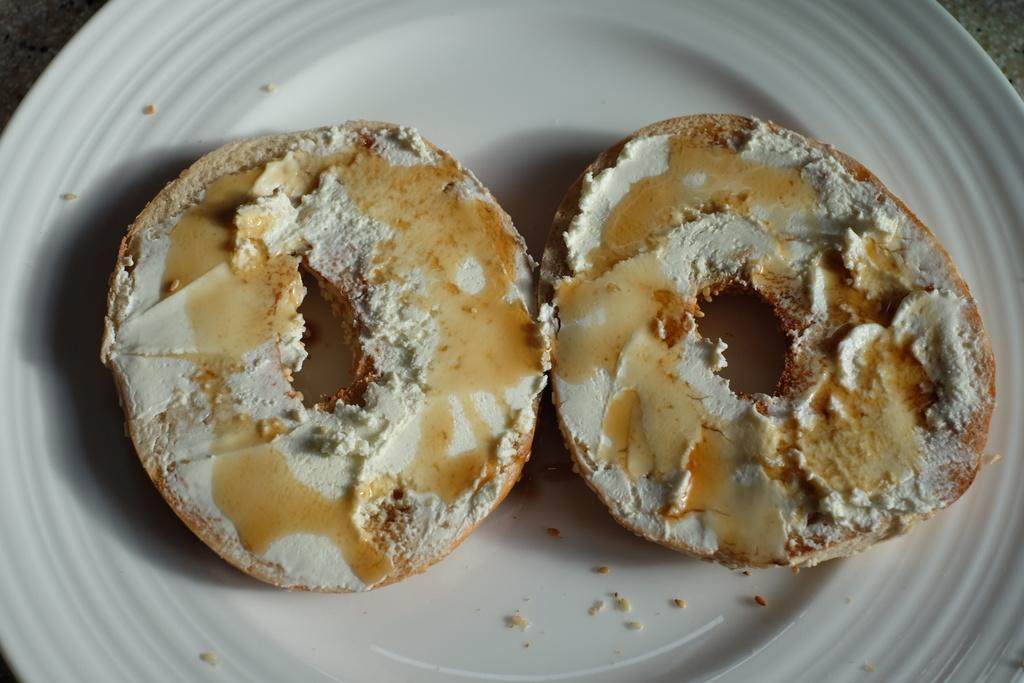What can be seen in the image? There are food items in the image. What is the color of the plate on which the food items are placed? The plate is white in color. What type of stick can be seen hanging from the curtain in the image? There is no stick or curtain present in the image; it only features food items on a white plate. 